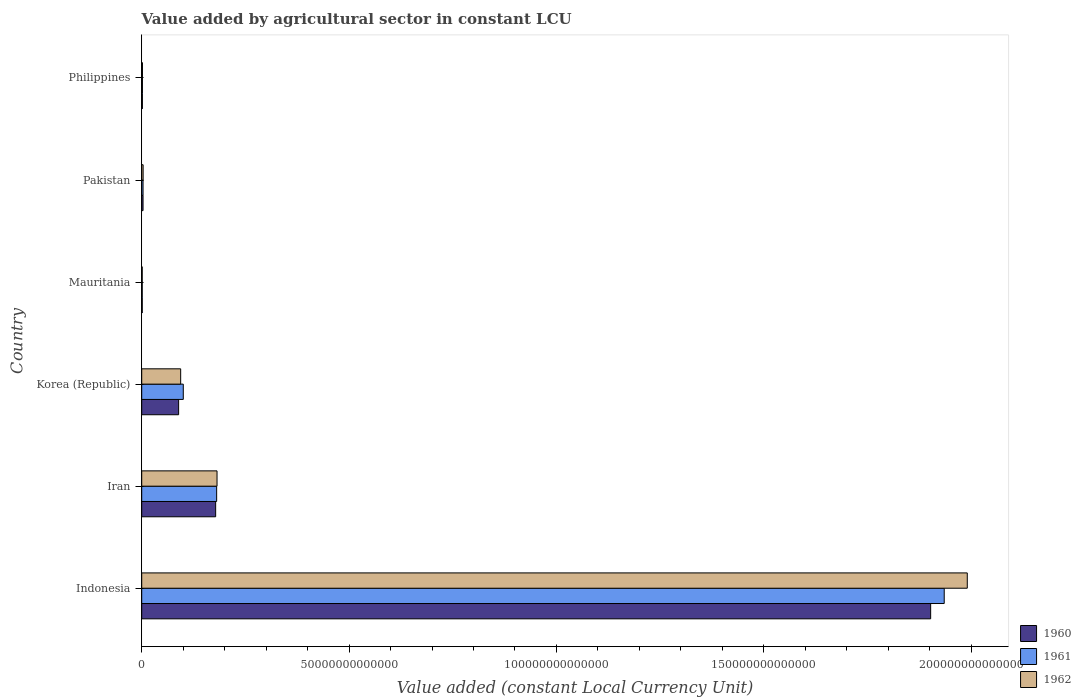How many groups of bars are there?
Ensure brevity in your answer.  6. Are the number of bars on each tick of the Y-axis equal?
Provide a succinct answer. Yes. What is the label of the 5th group of bars from the top?
Make the answer very short. Iran. In how many cases, is the number of bars for a given country not equal to the number of legend labels?
Ensure brevity in your answer.  0. What is the value added by agricultural sector in 1962 in Philippines?
Your answer should be very brief. 1.81e+11. Across all countries, what is the maximum value added by agricultural sector in 1962?
Your answer should be very brief. 1.99e+14. Across all countries, what is the minimum value added by agricultural sector in 1960?
Give a very brief answer. 1.27e+11. In which country was the value added by agricultural sector in 1962 minimum?
Your answer should be very brief. Mauritania. What is the total value added by agricultural sector in 1960 in the graph?
Ensure brevity in your answer.  2.18e+14. What is the difference between the value added by agricultural sector in 1960 in Iran and that in Mauritania?
Ensure brevity in your answer.  1.77e+13. What is the difference between the value added by agricultural sector in 1960 in Pakistan and the value added by agricultural sector in 1961 in Korea (Republic)?
Your answer should be compact. -9.70e+12. What is the average value added by agricultural sector in 1962 per country?
Your answer should be compact. 3.79e+13. What is the difference between the value added by agricultural sector in 1962 and value added by agricultural sector in 1960 in Mauritania?
Offer a terse response. -7.67e+09. In how many countries, is the value added by agricultural sector in 1962 greater than 160000000000000 LCU?
Your response must be concise. 1. What is the ratio of the value added by agricultural sector in 1960 in Iran to that in Korea (Republic)?
Your answer should be compact. 2. Is the difference between the value added by agricultural sector in 1962 in Indonesia and Korea (Republic) greater than the difference between the value added by agricultural sector in 1960 in Indonesia and Korea (Republic)?
Your answer should be compact. Yes. What is the difference between the highest and the second highest value added by agricultural sector in 1962?
Keep it short and to the point. 1.81e+14. What is the difference between the highest and the lowest value added by agricultural sector in 1962?
Give a very brief answer. 1.99e+14. In how many countries, is the value added by agricultural sector in 1962 greater than the average value added by agricultural sector in 1962 taken over all countries?
Make the answer very short. 1. What is the difference between two consecutive major ticks on the X-axis?
Ensure brevity in your answer.  5.00e+13. What is the title of the graph?
Your response must be concise. Value added by agricultural sector in constant LCU. What is the label or title of the X-axis?
Your answer should be very brief. Value added (constant Local Currency Unit). What is the Value added (constant Local Currency Unit) in 1960 in Indonesia?
Keep it short and to the point. 1.90e+14. What is the Value added (constant Local Currency Unit) of 1961 in Indonesia?
Provide a succinct answer. 1.94e+14. What is the Value added (constant Local Currency Unit) of 1962 in Indonesia?
Give a very brief answer. 1.99e+14. What is the Value added (constant Local Currency Unit) in 1960 in Iran?
Provide a succinct answer. 1.78e+13. What is the Value added (constant Local Currency Unit) of 1961 in Iran?
Make the answer very short. 1.81e+13. What is the Value added (constant Local Currency Unit) of 1962 in Iran?
Ensure brevity in your answer.  1.82e+13. What is the Value added (constant Local Currency Unit) of 1960 in Korea (Republic)?
Provide a short and direct response. 8.90e+12. What is the Value added (constant Local Currency Unit) in 1961 in Korea (Republic)?
Ensure brevity in your answer.  1.00e+13. What is the Value added (constant Local Currency Unit) in 1962 in Korea (Republic)?
Offer a terse response. 9.39e+12. What is the Value added (constant Local Currency Unit) of 1960 in Mauritania?
Provide a short and direct response. 1.27e+11. What is the Value added (constant Local Currency Unit) in 1961 in Mauritania?
Give a very brief answer. 1.23e+11. What is the Value added (constant Local Currency Unit) in 1962 in Mauritania?
Offer a very short reply. 1.20e+11. What is the Value added (constant Local Currency Unit) of 1960 in Pakistan?
Keep it short and to the point. 3.20e+11. What is the Value added (constant Local Currency Unit) in 1961 in Pakistan?
Your answer should be compact. 3.19e+11. What is the Value added (constant Local Currency Unit) of 1962 in Pakistan?
Ensure brevity in your answer.  3.39e+11. What is the Value added (constant Local Currency Unit) of 1960 in Philippines?
Ensure brevity in your answer.  1.62e+11. What is the Value added (constant Local Currency Unit) of 1961 in Philippines?
Your answer should be very brief. 1.73e+11. What is the Value added (constant Local Currency Unit) in 1962 in Philippines?
Make the answer very short. 1.81e+11. Across all countries, what is the maximum Value added (constant Local Currency Unit) of 1960?
Your answer should be very brief. 1.90e+14. Across all countries, what is the maximum Value added (constant Local Currency Unit) of 1961?
Ensure brevity in your answer.  1.94e+14. Across all countries, what is the maximum Value added (constant Local Currency Unit) of 1962?
Ensure brevity in your answer.  1.99e+14. Across all countries, what is the minimum Value added (constant Local Currency Unit) in 1960?
Ensure brevity in your answer.  1.27e+11. Across all countries, what is the minimum Value added (constant Local Currency Unit) in 1961?
Provide a succinct answer. 1.23e+11. Across all countries, what is the minimum Value added (constant Local Currency Unit) of 1962?
Keep it short and to the point. 1.20e+11. What is the total Value added (constant Local Currency Unit) of 1960 in the graph?
Your answer should be very brief. 2.18e+14. What is the total Value added (constant Local Currency Unit) in 1961 in the graph?
Offer a terse response. 2.22e+14. What is the total Value added (constant Local Currency Unit) in 1962 in the graph?
Keep it short and to the point. 2.27e+14. What is the difference between the Value added (constant Local Currency Unit) of 1960 in Indonesia and that in Iran?
Give a very brief answer. 1.72e+14. What is the difference between the Value added (constant Local Currency Unit) of 1961 in Indonesia and that in Iran?
Your answer should be very brief. 1.75e+14. What is the difference between the Value added (constant Local Currency Unit) in 1962 in Indonesia and that in Iran?
Keep it short and to the point. 1.81e+14. What is the difference between the Value added (constant Local Currency Unit) in 1960 in Indonesia and that in Korea (Republic)?
Offer a very short reply. 1.81e+14. What is the difference between the Value added (constant Local Currency Unit) of 1961 in Indonesia and that in Korea (Republic)?
Keep it short and to the point. 1.83e+14. What is the difference between the Value added (constant Local Currency Unit) of 1962 in Indonesia and that in Korea (Republic)?
Your answer should be very brief. 1.90e+14. What is the difference between the Value added (constant Local Currency Unit) in 1960 in Indonesia and that in Mauritania?
Provide a succinct answer. 1.90e+14. What is the difference between the Value added (constant Local Currency Unit) of 1961 in Indonesia and that in Mauritania?
Your answer should be very brief. 1.93e+14. What is the difference between the Value added (constant Local Currency Unit) in 1962 in Indonesia and that in Mauritania?
Give a very brief answer. 1.99e+14. What is the difference between the Value added (constant Local Currency Unit) of 1960 in Indonesia and that in Pakistan?
Your answer should be compact. 1.90e+14. What is the difference between the Value added (constant Local Currency Unit) in 1961 in Indonesia and that in Pakistan?
Provide a succinct answer. 1.93e+14. What is the difference between the Value added (constant Local Currency Unit) of 1962 in Indonesia and that in Pakistan?
Provide a short and direct response. 1.99e+14. What is the difference between the Value added (constant Local Currency Unit) of 1960 in Indonesia and that in Philippines?
Make the answer very short. 1.90e+14. What is the difference between the Value added (constant Local Currency Unit) in 1961 in Indonesia and that in Philippines?
Keep it short and to the point. 1.93e+14. What is the difference between the Value added (constant Local Currency Unit) of 1962 in Indonesia and that in Philippines?
Your response must be concise. 1.99e+14. What is the difference between the Value added (constant Local Currency Unit) of 1960 in Iran and that in Korea (Republic)?
Offer a terse response. 8.93e+12. What is the difference between the Value added (constant Local Currency Unit) of 1961 in Iran and that in Korea (Republic)?
Offer a terse response. 8.05e+12. What is the difference between the Value added (constant Local Currency Unit) of 1962 in Iran and that in Korea (Republic)?
Your response must be concise. 8.77e+12. What is the difference between the Value added (constant Local Currency Unit) in 1960 in Iran and that in Mauritania?
Ensure brevity in your answer.  1.77e+13. What is the difference between the Value added (constant Local Currency Unit) of 1961 in Iran and that in Mauritania?
Give a very brief answer. 1.79e+13. What is the difference between the Value added (constant Local Currency Unit) in 1962 in Iran and that in Mauritania?
Make the answer very short. 1.80e+13. What is the difference between the Value added (constant Local Currency Unit) of 1960 in Iran and that in Pakistan?
Provide a short and direct response. 1.75e+13. What is the difference between the Value added (constant Local Currency Unit) in 1961 in Iran and that in Pakistan?
Make the answer very short. 1.78e+13. What is the difference between the Value added (constant Local Currency Unit) in 1962 in Iran and that in Pakistan?
Provide a succinct answer. 1.78e+13. What is the difference between the Value added (constant Local Currency Unit) in 1960 in Iran and that in Philippines?
Ensure brevity in your answer.  1.77e+13. What is the difference between the Value added (constant Local Currency Unit) in 1961 in Iran and that in Philippines?
Offer a very short reply. 1.79e+13. What is the difference between the Value added (constant Local Currency Unit) of 1962 in Iran and that in Philippines?
Offer a terse response. 1.80e+13. What is the difference between the Value added (constant Local Currency Unit) in 1960 in Korea (Republic) and that in Mauritania?
Make the answer very short. 8.77e+12. What is the difference between the Value added (constant Local Currency Unit) of 1961 in Korea (Republic) and that in Mauritania?
Offer a very short reply. 9.90e+12. What is the difference between the Value added (constant Local Currency Unit) in 1962 in Korea (Republic) and that in Mauritania?
Give a very brief answer. 9.27e+12. What is the difference between the Value added (constant Local Currency Unit) in 1960 in Korea (Republic) and that in Pakistan?
Offer a very short reply. 8.58e+12. What is the difference between the Value added (constant Local Currency Unit) of 1961 in Korea (Republic) and that in Pakistan?
Ensure brevity in your answer.  9.70e+12. What is the difference between the Value added (constant Local Currency Unit) in 1962 in Korea (Republic) and that in Pakistan?
Ensure brevity in your answer.  9.05e+12. What is the difference between the Value added (constant Local Currency Unit) in 1960 in Korea (Republic) and that in Philippines?
Provide a short and direct response. 8.74e+12. What is the difference between the Value added (constant Local Currency Unit) in 1961 in Korea (Republic) and that in Philippines?
Provide a succinct answer. 9.85e+12. What is the difference between the Value added (constant Local Currency Unit) in 1962 in Korea (Republic) and that in Philippines?
Your answer should be compact. 9.21e+12. What is the difference between the Value added (constant Local Currency Unit) in 1960 in Mauritania and that in Pakistan?
Your answer should be very brief. -1.93e+11. What is the difference between the Value added (constant Local Currency Unit) in 1961 in Mauritania and that in Pakistan?
Ensure brevity in your answer.  -1.96e+11. What is the difference between the Value added (constant Local Currency Unit) of 1962 in Mauritania and that in Pakistan?
Your answer should be very brief. -2.20e+11. What is the difference between the Value added (constant Local Currency Unit) of 1960 in Mauritania and that in Philippines?
Ensure brevity in your answer.  -3.47e+1. What is the difference between the Value added (constant Local Currency Unit) in 1961 in Mauritania and that in Philippines?
Ensure brevity in your answer.  -4.95e+1. What is the difference between the Value added (constant Local Currency Unit) of 1962 in Mauritania and that in Philippines?
Your response must be concise. -6.11e+1. What is the difference between the Value added (constant Local Currency Unit) of 1960 in Pakistan and that in Philippines?
Your answer should be very brief. 1.58e+11. What is the difference between the Value added (constant Local Currency Unit) of 1961 in Pakistan and that in Philippines?
Offer a very short reply. 1.47e+11. What is the difference between the Value added (constant Local Currency Unit) of 1962 in Pakistan and that in Philippines?
Keep it short and to the point. 1.58e+11. What is the difference between the Value added (constant Local Currency Unit) in 1960 in Indonesia and the Value added (constant Local Currency Unit) in 1961 in Iran?
Provide a short and direct response. 1.72e+14. What is the difference between the Value added (constant Local Currency Unit) in 1960 in Indonesia and the Value added (constant Local Currency Unit) in 1962 in Iran?
Keep it short and to the point. 1.72e+14. What is the difference between the Value added (constant Local Currency Unit) in 1961 in Indonesia and the Value added (constant Local Currency Unit) in 1962 in Iran?
Keep it short and to the point. 1.75e+14. What is the difference between the Value added (constant Local Currency Unit) in 1960 in Indonesia and the Value added (constant Local Currency Unit) in 1961 in Korea (Republic)?
Give a very brief answer. 1.80e+14. What is the difference between the Value added (constant Local Currency Unit) of 1960 in Indonesia and the Value added (constant Local Currency Unit) of 1962 in Korea (Republic)?
Offer a terse response. 1.81e+14. What is the difference between the Value added (constant Local Currency Unit) of 1961 in Indonesia and the Value added (constant Local Currency Unit) of 1962 in Korea (Republic)?
Make the answer very short. 1.84e+14. What is the difference between the Value added (constant Local Currency Unit) in 1960 in Indonesia and the Value added (constant Local Currency Unit) in 1961 in Mauritania?
Provide a short and direct response. 1.90e+14. What is the difference between the Value added (constant Local Currency Unit) of 1960 in Indonesia and the Value added (constant Local Currency Unit) of 1962 in Mauritania?
Give a very brief answer. 1.90e+14. What is the difference between the Value added (constant Local Currency Unit) of 1961 in Indonesia and the Value added (constant Local Currency Unit) of 1962 in Mauritania?
Your answer should be compact. 1.93e+14. What is the difference between the Value added (constant Local Currency Unit) of 1960 in Indonesia and the Value added (constant Local Currency Unit) of 1961 in Pakistan?
Offer a terse response. 1.90e+14. What is the difference between the Value added (constant Local Currency Unit) in 1960 in Indonesia and the Value added (constant Local Currency Unit) in 1962 in Pakistan?
Provide a short and direct response. 1.90e+14. What is the difference between the Value added (constant Local Currency Unit) of 1961 in Indonesia and the Value added (constant Local Currency Unit) of 1962 in Pakistan?
Your response must be concise. 1.93e+14. What is the difference between the Value added (constant Local Currency Unit) in 1960 in Indonesia and the Value added (constant Local Currency Unit) in 1961 in Philippines?
Your response must be concise. 1.90e+14. What is the difference between the Value added (constant Local Currency Unit) in 1960 in Indonesia and the Value added (constant Local Currency Unit) in 1962 in Philippines?
Give a very brief answer. 1.90e+14. What is the difference between the Value added (constant Local Currency Unit) in 1961 in Indonesia and the Value added (constant Local Currency Unit) in 1962 in Philippines?
Your response must be concise. 1.93e+14. What is the difference between the Value added (constant Local Currency Unit) of 1960 in Iran and the Value added (constant Local Currency Unit) of 1961 in Korea (Republic)?
Your answer should be compact. 7.81e+12. What is the difference between the Value added (constant Local Currency Unit) of 1960 in Iran and the Value added (constant Local Currency Unit) of 1962 in Korea (Republic)?
Keep it short and to the point. 8.44e+12. What is the difference between the Value added (constant Local Currency Unit) in 1961 in Iran and the Value added (constant Local Currency Unit) in 1962 in Korea (Republic)?
Ensure brevity in your answer.  8.68e+12. What is the difference between the Value added (constant Local Currency Unit) in 1960 in Iran and the Value added (constant Local Currency Unit) in 1961 in Mauritania?
Your answer should be very brief. 1.77e+13. What is the difference between the Value added (constant Local Currency Unit) in 1960 in Iran and the Value added (constant Local Currency Unit) in 1962 in Mauritania?
Your answer should be compact. 1.77e+13. What is the difference between the Value added (constant Local Currency Unit) in 1961 in Iran and the Value added (constant Local Currency Unit) in 1962 in Mauritania?
Keep it short and to the point. 1.80e+13. What is the difference between the Value added (constant Local Currency Unit) of 1960 in Iran and the Value added (constant Local Currency Unit) of 1961 in Pakistan?
Make the answer very short. 1.75e+13. What is the difference between the Value added (constant Local Currency Unit) in 1960 in Iran and the Value added (constant Local Currency Unit) in 1962 in Pakistan?
Offer a very short reply. 1.75e+13. What is the difference between the Value added (constant Local Currency Unit) in 1961 in Iran and the Value added (constant Local Currency Unit) in 1962 in Pakistan?
Make the answer very short. 1.77e+13. What is the difference between the Value added (constant Local Currency Unit) of 1960 in Iran and the Value added (constant Local Currency Unit) of 1961 in Philippines?
Your answer should be compact. 1.77e+13. What is the difference between the Value added (constant Local Currency Unit) in 1960 in Iran and the Value added (constant Local Currency Unit) in 1962 in Philippines?
Provide a succinct answer. 1.76e+13. What is the difference between the Value added (constant Local Currency Unit) of 1961 in Iran and the Value added (constant Local Currency Unit) of 1962 in Philippines?
Your answer should be compact. 1.79e+13. What is the difference between the Value added (constant Local Currency Unit) of 1960 in Korea (Republic) and the Value added (constant Local Currency Unit) of 1961 in Mauritania?
Provide a succinct answer. 8.77e+12. What is the difference between the Value added (constant Local Currency Unit) of 1960 in Korea (Republic) and the Value added (constant Local Currency Unit) of 1962 in Mauritania?
Provide a succinct answer. 8.78e+12. What is the difference between the Value added (constant Local Currency Unit) of 1961 in Korea (Republic) and the Value added (constant Local Currency Unit) of 1962 in Mauritania?
Keep it short and to the point. 9.90e+12. What is the difference between the Value added (constant Local Currency Unit) in 1960 in Korea (Republic) and the Value added (constant Local Currency Unit) in 1961 in Pakistan?
Ensure brevity in your answer.  8.58e+12. What is the difference between the Value added (constant Local Currency Unit) of 1960 in Korea (Republic) and the Value added (constant Local Currency Unit) of 1962 in Pakistan?
Make the answer very short. 8.56e+12. What is the difference between the Value added (constant Local Currency Unit) in 1961 in Korea (Republic) and the Value added (constant Local Currency Unit) in 1962 in Pakistan?
Your answer should be very brief. 9.68e+12. What is the difference between the Value added (constant Local Currency Unit) of 1960 in Korea (Republic) and the Value added (constant Local Currency Unit) of 1961 in Philippines?
Your response must be concise. 8.73e+12. What is the difference between the Value added (constant Local Currency Unit) of 1960 in Korea (Republic) and the Value added (constant Local Currency Unit) of 1962 in Philippines?
Your response must be concise. 8.72e+12. What is the difference between the Value added (constant Local Currency Unit) in 1961 in Korea (Republic) and the Value added (constant Local Currency Unit) in 1962 in Philippines?
Offer a very short reply. 9.84e+12. What is the difference between the Value added (constant Local Currency Unit) of 1960 in Mauritania and the Value added (constant Local Currency Unit) of 1961 in Pakistan?
Offer a very short reply. -1.92e+11. What is the difference between the Value added (constant Local Currency Unit) in 1960 in Mauritania and the Value added (constant Local Currency Unit) in 1962 in Pakistan?
Your answer should be very brief. -2.12e+11. What is the difference between the Value added (constant Local Currency Unit) of 1961 in Mauritania and the Value added (constant Local Currency Unit) of 1962 in Pakistan?
Make the answer very short. -2.16e+11. What is the difference between the Value added (constant Local Currency Unit) of 1960 in Mauritania and the Value added (constant Local Currency Unit) of 1961 in Philippines?
Ensure brevity in your answer.  -4.55e+1. What is the difference between the Value added (constant Local Currency Unit) in 1960 in Mauritania and the Value added (constant Local Currency Unit) in 1962 in Philippines?
Give a very brief answer. -5.34e+1. What is the difference between the Value added (constant Local Currency Unit) of 1961 in Mauritania and the Value added (constant Local Currency Unit) of 1962 in Philippines?
Ensure brevity in your answer.  -5.74e+1. What is the difference between the Value added (constant Local Currency Unit) in 1960 in Pakistan and the Value added (constant Local Currency Unit) in 1961 in Philippines?
Offer a terse response. 1.47e+11. What is the difference between the Value added (constant Local Currency Unit) of 1960 in Pakistan and the Value added (constant Local Currency Unit) of 1962 in Philippines?
Your answer should be very brief. 1.39e+11. What is the difference between the Value added (constant Local Currency Unit) of 1961 in Pakistan and the Value added (constant Local Currency Unit) of 1962 in Philippines?
Ensure brevity in your answer.  1.39e+11. What is the average Value added (constant Local Currency Unit) of 1960 per country?
Keep it short and to the point. 3.63e+13. What is the average Value added (constant Local Currency Unit) of 1961 per country?
Your response must be concise. 3.70e+13. What is the average Value added (constant Local Currency Unit) of 1962 per country?
Your answer should be very brief. 3.79e+13. What is the difference between the Value added (constant Local Currency Unit) in 1960 and Value added (constant Local Currency Unit) in 1961 in Indonesia?
Ensure brevity in your answer.  -3.27e+12. What is the difference between the Value added (constant Local Currency Unit) in 1960 and Value added (constant Local Currency Unit) in 1962 in Indonesia?
Offer a very short reply. -8.83e+12. What is the difference between the Value added (constant Local Currency Unit) in 1961 and Value added (constant Local Currency Unit) in 1962 in Indonesia?
Your response must be concise. -5.56e+12. What is the difference between the Value added (constant Local Currency Unit) of 1960 and Value added (constant Local Currency Unit) of 1961 in Iran?
Your answer should be very brief. -2.42e+11. What is the difference between the Value added (constant Local Currency Unit) of 1960 and Value added (constant Local Currency Unit) of 1962 in Iran?
Make the answer very short. -3.32e+11. What is the difference between the Value added (constant Local Currency Unit) in 1961 and Value added (constant Local Currency Unit) in 1962 in Iran?
Provide a succinct answer. -8.95e+1. What is the difference between the Value added (constant Local Currency Unit) in 1960 and Value added (constant Local Currency Unit) in 1961 in Korea (Republic)?
Your answer should be very brief. -1.12e+12. What is the difference between the Value added (constant Local Currency Unit) of 1960 and Value added (constant Local Currency Unit) of 1962 in Korea (Republic)?
Provide a short and direct response. -4.93e+11. What is the difference between the Value added (constant Local Currency Unit) in 1961 and Value added (constant Local Currency Unit) in 1962 in Korea (Republic)?
Make the answer very short. 6.31e+11. What is the difference between the Value added (constant Local Currency Unit) in 1960 and Value added (constant Local Currency Unit) in 1961 in Mauritania?
Ensure brevity in your answer.  4.01e+09. What is the difference between the Value added (constant Local Currency Unit) in 1960 and Value added (constant Local Currency Unit) in 1962 in Mauritania?
Your answer should be compact. 7.67e+09. What is the difference between the Value added (constant Local Currency Unit) of 1961 and Value added (constant Local Currency Unit) of 1962 in Mauritania?
Offer a very short reply. 3.65e+09. What is the difference between the Value added (constant Local Currency Unit) in 1960 and Value added (constant Local Currency Unit) in 1961 in Pakistan?
Offer a terse response. 6.46e+08. What is the difference between the Value added (constant Local Currency Unit) of 1960 and Value added (constant Local Currency Unit) of 1962 in Pakistan?
Give a very brief answer. -1.91e+1. What is the difference between the Value added (constant Local Currency Unit) of 1961 and Value added (constant Local Currency Unit) of 1962 in Pakistan?
Your answer should be very brief. -1.97e+1. What is the difference between the Value added (constant Local Currency Unit) of 1960 and Value added (constant Local Currency Unit) of 1961 in Philippines?
Provide a succinct answer. -1.08e+1. What is the difference between the Value added (constant Local Currency Unit) of 1960 and Value added (constant Local Currency Unit) of 1962 in Philippines?
Your answer should be compact. -1.87e+1. What is the difference between the Value added (constant Local Currency Unit) of 1961 and Value added (constant Local Currency Unit) of 1962 in Philippines?
Your response must be concise. -7.86e+09. What is the ratio of the Value added (constant Local Currency Unit) of 1960 in Indonesia to that in Iran?
Your response must be concise. 10.67. What is the ratio of the Value added (constant Local Currency Unit) in 1961 in Indonesia to that in Iran?
Give a very brief answer. 10.71. What is the ratio of the Value added (constant Local Currency Unit) in 1962 in Indonesia to that in Iran?
Offer a terse response. 10.96. What is the ratio of the Value added (constant Local Currency Unit) of 1960 in Indonesia to that in Korea (Republic)?
Your answer should be very brief. 21.38. What is the ratio of the Value added (constant Local Currency Unit) of 1961 in Indonesia to that in Korea (Republic)?
Keep it short and to the point. 19.31. What is the ratio of the Value added (constant Local Currency Unit) of 1962 in Indonesia to that in Korea (Republic)?
Your response must be concise. 21.2. What is the ratio of the Value added (constant Local Currency Unit) of 1960 in Indonesia to that in Mauritania?
Your answer should be compact. 1494.5. What is the ratio of the Value added (constant Local Currency Unit) in 1961 in Indonesia to that in Mauritania?
Keep it short and to the point. 1569.7. What is the ratio of the Value added (constant Local Currency Unit) in 1962 in Indonesia to that in Mauritania?
Your answer should be compact. 1664.14. What is the ratio of the Value added (constant Local Currency Unit) in 1960 in Indonesia to that in Pakistan?
Offer a terse response. 594.38. What is the ratio of the Value added (constant Local Currency Unit) in 1961 in Indonesia to that in Pakistan?
Give a very brief answer. 605.82. What is the ratio of the Value added (constant Local Currency Unit) in 1962 in Indonesia to that in Pakistan?
Provide a succinct answer. 586.95. What is the ratio of the Value added (constant Local Currency Unit) in 1960 in Indonesia to that in Philippines?
Provide a short and direct response. 1174.47. What is the ratio of the Value added (constant Local Currency Unit) in 1961 in Indonesia to that in Philippines?
Keep it short and to the point. 1119.74. What is the ratio of the Value added (constant Local Currency Unit) of 1962 in Indonesia to that in Philippines?
Make the answer very short. 1101.78. What is the ratio of the Value added (constant Local Currency Unit) in 1960 in Iran to that in Korea (Republic)?
Offer a terse response. 2. What is the ratio of the Value added (constant Local Currency Unit) in 1961 in Iran to that in Korea (Republic)?
Offer a terse response. 1.8. What is the ratio of the Value added (constant Local Currency Unit) in 1962 in Iran to that in Korea (Republic)?
Provide a succinct answer. 1.93. What is the ratio of the Value added (constant Local Currency Unit) of 1960 in Iran to that in Mauritania?
Provide a succinct answer. 140.05. What is the ratio of the Value added (constant Local Currency Unit) of 1961 in Iran to that in Mauritania?
Make the answer very short. 146.57. What is the ratio of the Value added (constant Local Currency Unit) of 1962 in Iran to that in Mauritania?
Ensure brevity in your answer.  151.8. What is the ratio of the Value added (constant Local Currency Unit) of 1960 in Iran to that in Pakistan?
Provide a succinct answer. 55.7. What is the ratio of the Value added (constant Local Currency Unit) in 1961 in Iran to that in Pakistan?
Your answer should be very brief. 56.57. What is the ratio of the Value added (constant Local Currency Unit) in 1962 in Iran to that in Pakistan?
Your response must be concise. 53.54. What is the ratio of the Value added (constant Local Currency Unit) of 1960 in Iran to that in Philippines?
Offer a terse response. 110.06. What is the ratio of the Value added (constant Local Currency Unit) in 1961 in Iran to that in Philippines?
Offer a terse response. 104.56. What is the ratio of the Value added (constant Local Currency Unit) in 1962 in Iran to that in Philippines?
Make the answer very short. 100.5. What is the ratio of the Value added (constant Local Currency Unit) in 1960 in Korea (Republic) to that in Mauritania?
Make the answer very short. 69.9. What is the ratio of the Value added (constant Local Currency Unit) of 1961 in Korea (Republic) to that in Mauritania?
Give a very brief answer. 81.29. What is the ratio of the Value added (constant Local Currency Unit) of 1962 in Korea (Republic) to that in Mauritania?
Your answer should be compact. 78.51. What is the ratio of the Value added (constant Local Currency Unit) of 1960 in Korea (Republic) to that in Pakistan?
Provide a short and direct response. 27.8. What is the ratio of the Value added (constant Local Currency Unit) in 1961 in Korea (Republic) to that in Pakistan?
Provide a short and direct response. 31.38. What is the ratio of the Value added (constant Local Currency Unit) in 1962 in Korea (Republic) to that in Pakistan?
Provide a short and direct response. 27.69. What is the ratio of the Value added (constant Local Currency Unit) in 1960 in Korea (Republic) to that in Philippines?
Your answer should be compact. 54.93. What is the ratio of the Value added (constant Local Currency Unit) in 1961 in Korea (Republic) to that in Philippines?
Offer a terse response. 57.99. What is the ratio of the Value added (constant Local Currency Unit) of 1962 in Korea (Republic) to that in Philippines?
Your answer should be very brief. 51.98. What is the ratio of the Value added (constant Local Currency Unit) in 1960 in Mauritania to that in Pakistan?
Provide a short and direct response. 0.4. What is the ratio of the Value added (constant Local Currency Unit) in 1961 in Mauritania to that in Pakistan?
Keep it short and to the point. 0.39. What is the ratio of the Value added (constant Local Currency Unit) in 1962 in Mauritania to that in Pakistan?
Give a very brief answer. 0.35. What is the ratio of the Value added (constant Local Currency Unit) of 1960 in Mauritania to that in Philippines?
Offer a very short reply. 0.79. What is the ratio of the Value added (constant Local Currency Unit) of 1961 in Mauritania to that in Philippines?
Keep it short and to the point. 0.71. What is the ratio of the Value added (constant Local Currency Unit) of 1962 in Mauritania to that in Philippines?
Give a very brief answer. 0.66. What is the ratio of the Value added (constant Local Currency Unit) in 1960 in Pakistan to that in Philippines?
Your answer should be compact. 1.98. What is the ratio of the Value added (constant Local Currency Unit) of 1961 in Pakistan to that in Philippines?
Your answer should be compact. 1.85. What is the ratio of the Value added (constant Local Currency Unit) of 1962 in Pakistan to that in Philippines?
Give a very brief answer. 1.88. What is the difference between the highest and the second highest Value added (constant Local Currency Unit) of 1960?
Your answer should be very brief. 1.72e+14. What is the difference between the highest and the second highest Value added (constant Local Currency Unit) of 1961?
Your answer should be compact. 1.75e+14. What is the difference between the highest and the second highest Value added (constant Local Currency Unit) of 1962?
Provide a short and direct response. 1.81e+14. What is the difference between the highest and the lowest Value added (constant Local Currency Unit) of 1960?
Your response must be concise. 1.90e+14. What is the difference between the highest and the lowest Value added (constant Local Currency Unit) of 1961?
Ensure brevity in your answer.  1.93e+14. What is the difference between the highest and the lowest Value added (constant Local Currency Unit) of 1962?
Provide a succinct answer. 1.99e+14. 